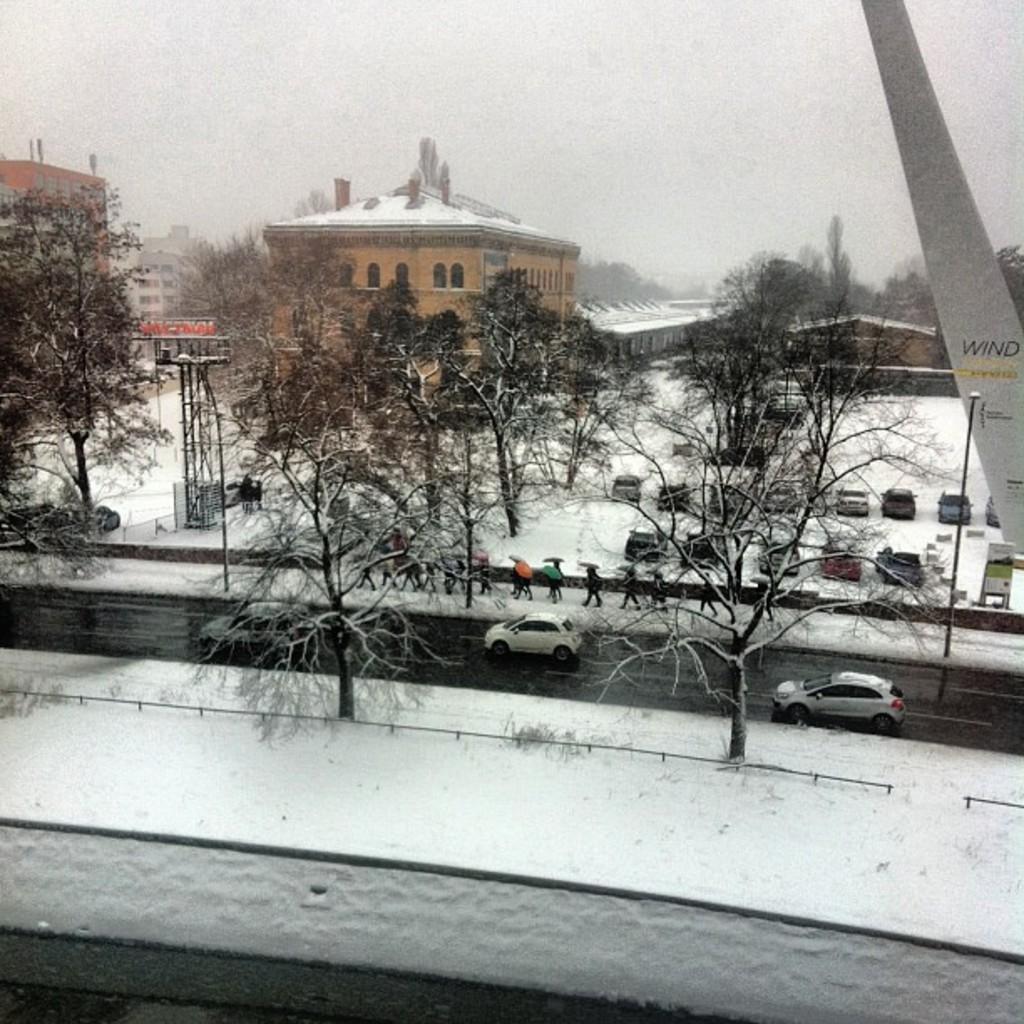Please provide a concise description of this image. In this picture we can see few vehicles, poles, trees and group of people, they are walking on the pathway, and also we can see snow and few buildings. 